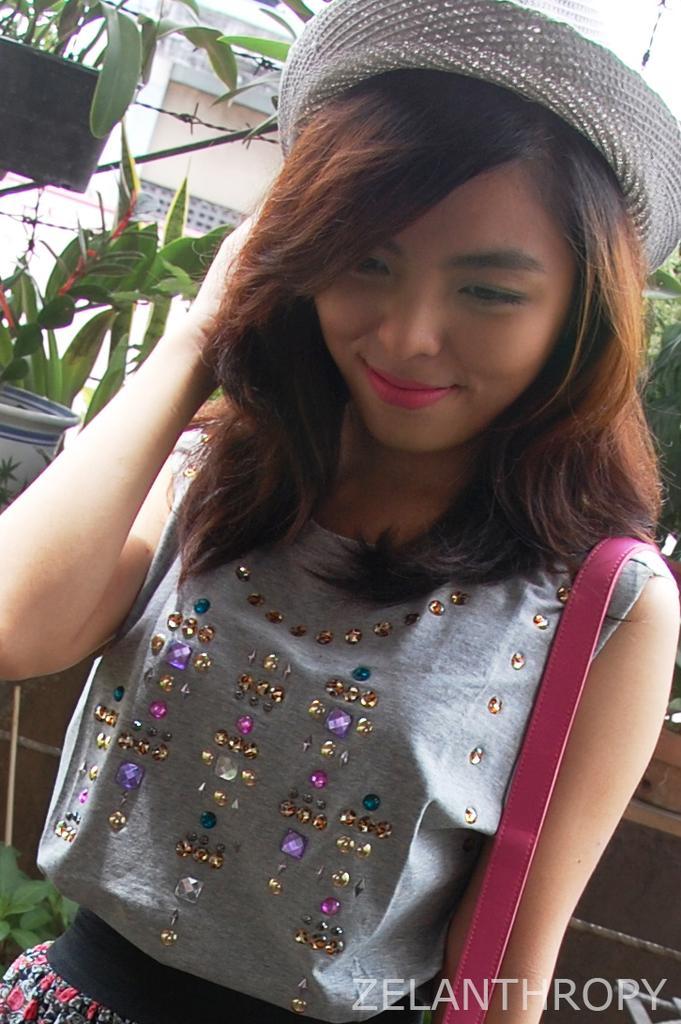In one or two sentences, can you explain what this image depicts? In this image I can see a person wearing gray color shirt and pink color bag, background I can see few plants in green color, a building in cream color and the sky is in white color. 